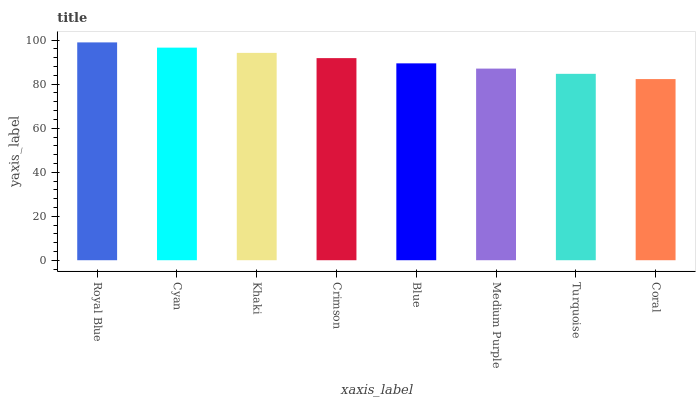Is Coral the minimum?
Answer yes or no. Yes. Is Royal Blue the maximum?
Answer yes or no. Yes. Is Cyan the minimum?
Answer yes or no. No. Is Cyan the maximum?
Answer yes or no. No. Is Royal Blue greater than Cyan?
Answer yes or no. Yes. Is Cyan less than Royal Blue?
Answer yes or no. Yes. Is Cyan greater than Royal Blue?
Answer yes or no. No. Is Royal Blue less than Cyan?
Answer yes or no. No. Is Crimson the high median?
Answer yes or no. Yes. Is Blue the low median?
Answer yes or no. Yes. Is Cyan the high median?
Answer yes or no. No. Is Turquoise the low median?
Answer yes or no. No. 